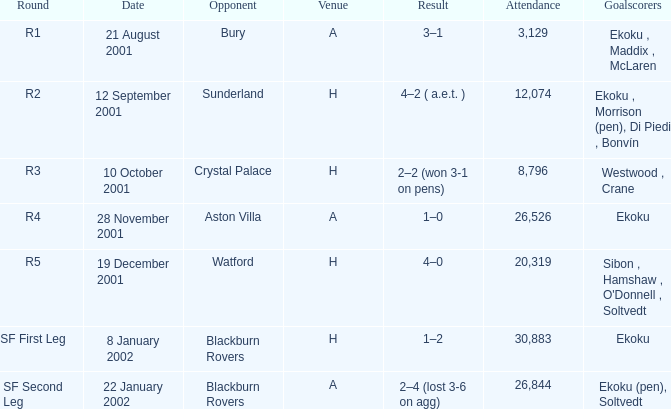When playing against sunderland, what is the final result? 4–2 ( a.e.t. ). 